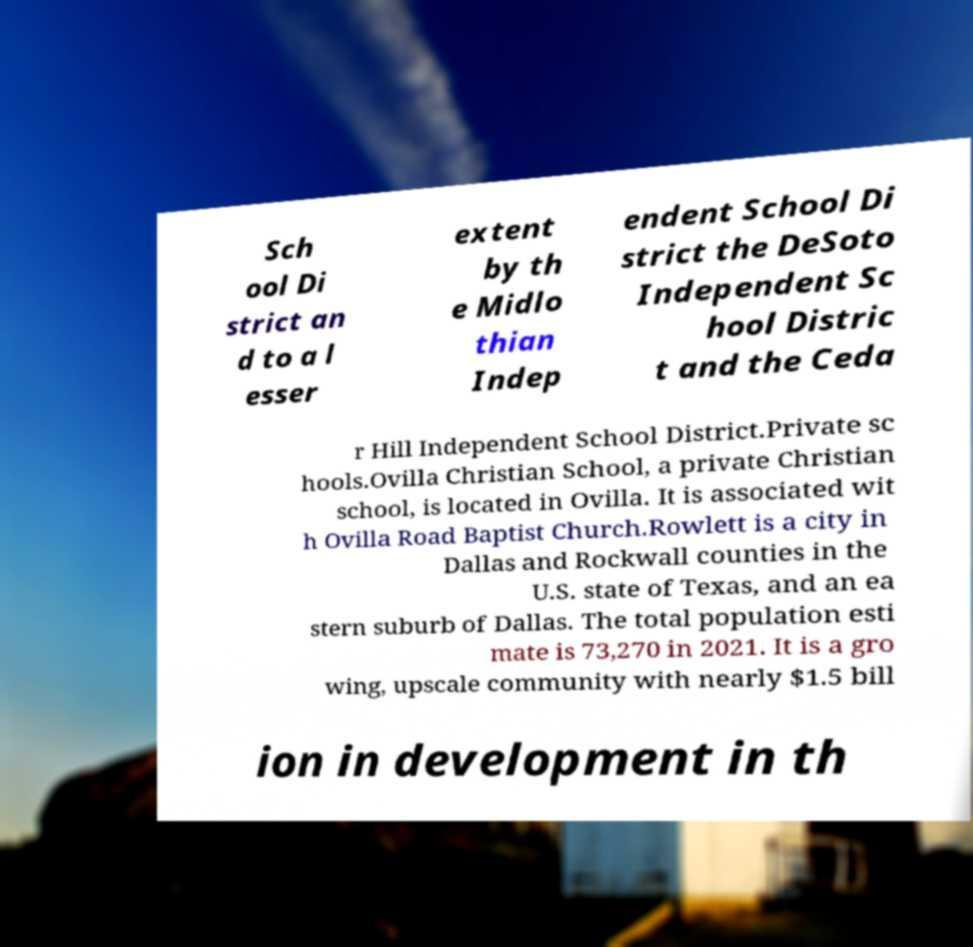Could you extract and type out the text from this image? Sch ool Di strict an d to a l esser extent by th e Midlo thian Indep endent School Di strict the DeSoto Independent Sc hool Distric t and the Ceda r Hill Independent School District.Private sc hools.Ovilla Christian School, a private Christian school, is located in Ovilla. It is associated wit h Ovilla Road Baptist Church.Rowlett is a city in Dallas and Rockwall counties in the U.S. state of Texas, and an ea stern suburb of Dallas. The total population esti mate is 73,270 in 2021. It is a gro wing, upscale community with nearly $1.5 bill ion in development in th 